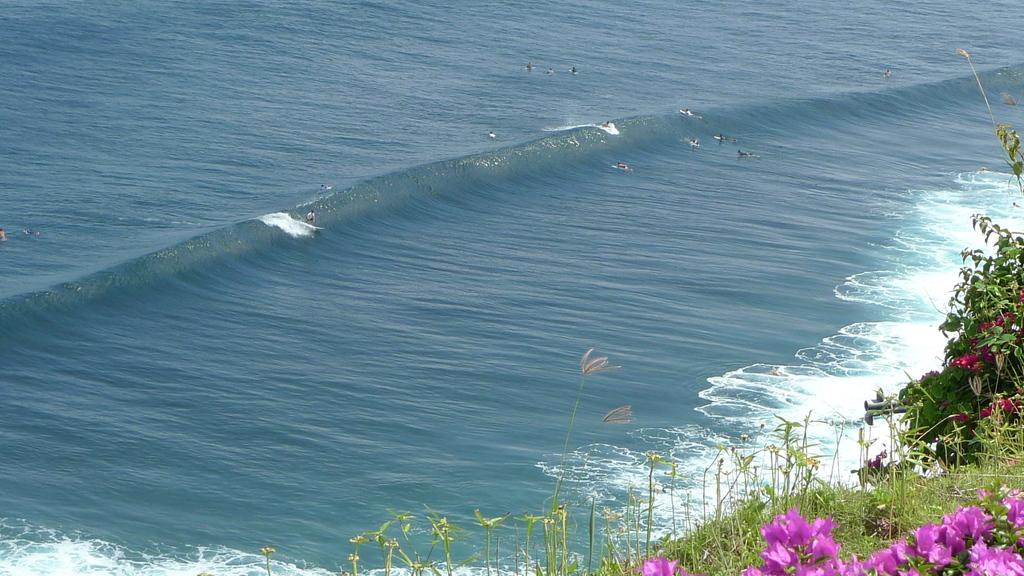What is the primary element in the image? There is water in the image. What are the people in the image doing? The people are in the water. What can be seen at the bottom of the image? There are plants at the bottom of the image. What type of flora is visible in the image? Flowers are visible in the image. What type of music can be heard playing in the background of the image? There is no music present in the image, as it is a visual representation and does not include sound. 